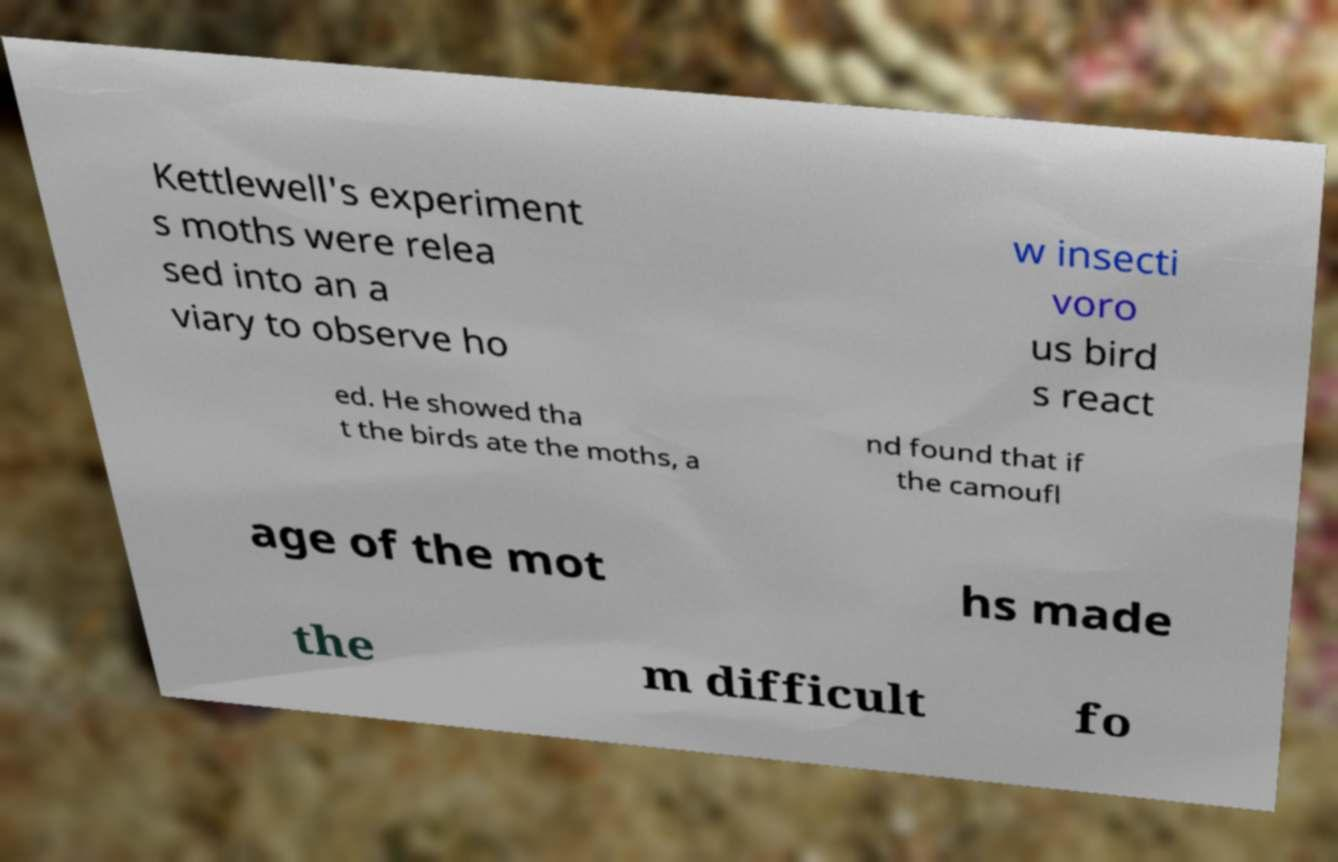Can you read and provide the text displayed in the image?This photo seems to have some interesting text. Can you extract and type it out for me? Kettlewell's experiment s moths were relea sed into an a viary to observe ho w insecti voro us bird s react ed. He showed tha t the birds ate the moths, a nd found that if the camoufl age of the mot hs made the m difficult fo 